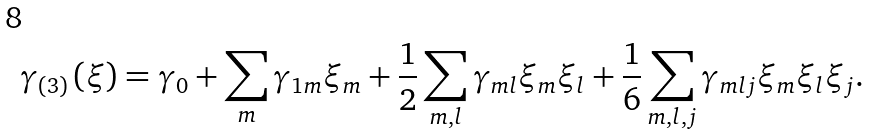Convert formula to latex. <formula><loc_0><loc_0><loc_500><loc_500>\gamma _ { \left ( 3 \right ) } \left ( \xi \right ) = \gamma _ { 0 } + \sum _ { m } \gamma _ { 1 m } \xi _ { m } + \frac { 1 } { 2 } \sum _ { m , l } \gamma _ { m l } \xi _ { m } \xi _ { l } + \frac { 1 } { 6 } \sum _ { m , l , j } \gamma _ { m l j } \xi _ { m } \xi _ { l } \xi _ { j } .</formula> 